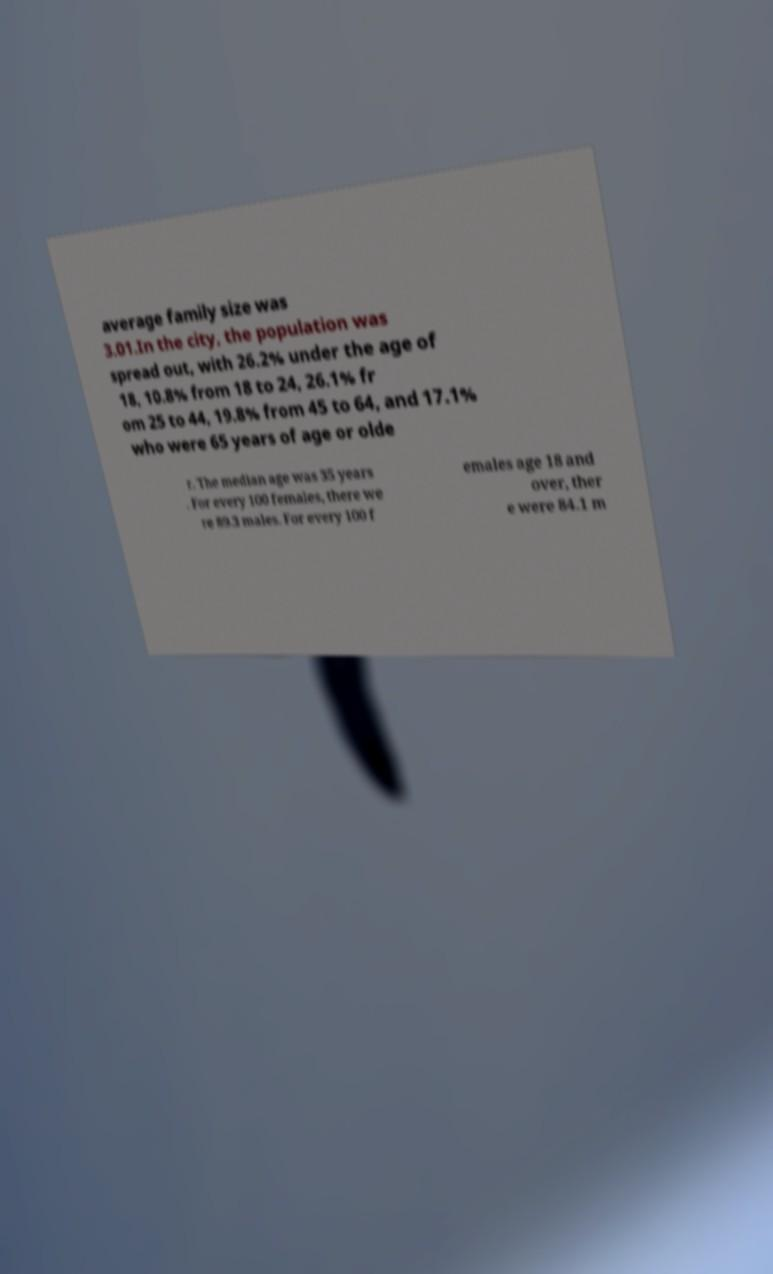Could you assist in decoding the text presented in this image and type it out clearly? average family size was 3.01.In the city, the population was spread out, with 26.2% under the age of 18, 10.8% from 18 to 24, 26.1% fr om 25 to 44, 19.8% from 45 to 64, and 17.1% who were 65 years of age or olde r. The median age was 35 years . For every 100 females, there we re 89.3 males. For every 100 f emales age 18 and over, ther e were 84.1 m 